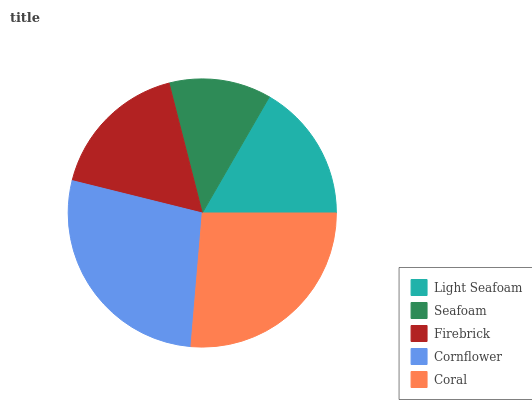Is Seafoam the minimum?
Answer yes or no. Yes. Is Cornflower the maximum?
Answer yes or no. Yes. Is Firebrick the minimum?
Answer yes or no. No. Is Firebrick the maximum?
Answer yes or no. No. Is Firebrick greater than Seafoam?
Answer yes or no. Yes. Is Seafoam less than Firebrick?
Answer yes or no. Yes. Is Seafoam greater than Firebrick?
Answer yes or no. No. Is Firebrick less than Seafoam?
Answer yes or no. No. Is Firebrick the high median?
Answer yes or no. Yes. Is Firebrick the low median?
Answer yes or no. Yes. Is Light Seafoam the high median?
Answer yes or no. No. Is Light Seafoam the low median?
Answer yes or no. No. 